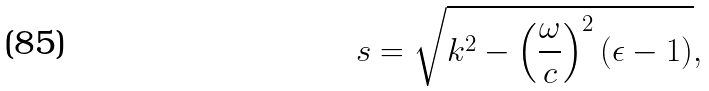Convert formula to latex. <formula><loc_0><loc_0><loc_500><loc_500>s = \sqrt { k ^ { 2 } - \left ( \frac { \omega } { c } \right ) ^ { 2 } ( \epsilon - 1 ) } , \\</formula> 